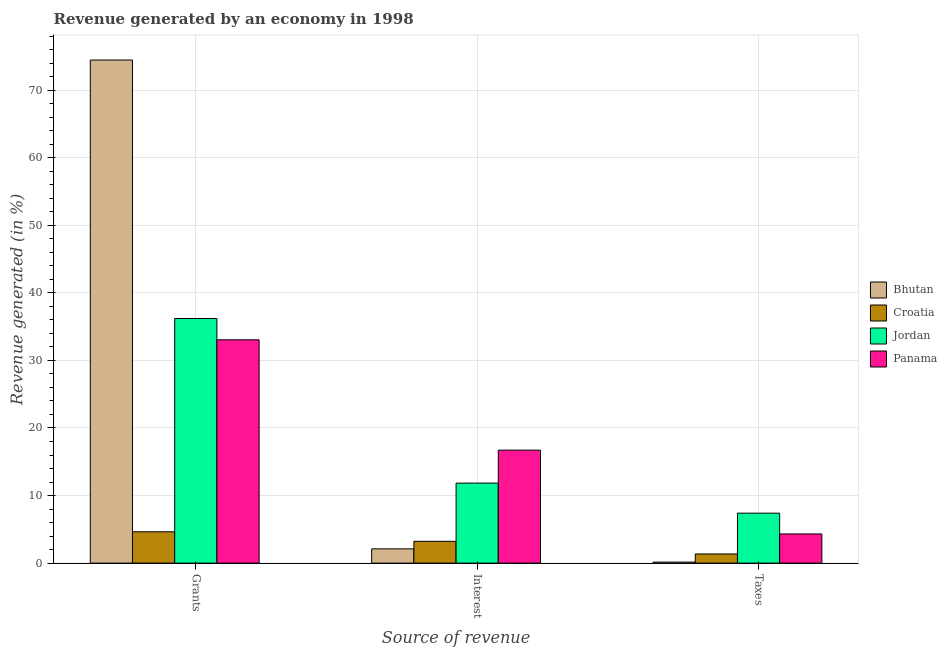Are the number of bars per tick equal to the number of legend labels?
Give a very brief answer. Yes. How many bars are there on the 3rd tick from the right?
Provide a succinct answer. 4. What is the label of the 3rd group of bars from the left?
Your response must be concise. Taxes. What is the percentage of revenue generated by taxes in Bhutan?
Offer a very short reply. 0.16. Across all countries, what is the maximum percentage of revenue generated by interest?
Your answer should be very brief. 16.72. Across all countries, what is the minimum percentage of revenue generated by interest?
Your answer should be very brief. 2.11. In which country was the percentage of revenue generated by taxes maximum?
Your response must be concise. Jordan. In which country was the percentage of revenue generated by taxes minimum?
Your answer should be compact. Bhutan. What is the total percentage of revenue generated by taxes in the graph?
Make the answer very short. 13.22. What is the difference between the percentage of revenue generated by grants in Bhutan and that in Jordan?
Provide a succinct answer. 38.25. What is the difference between the percentage of revenue generated by interest in Panama and the percentage of revenue generated by taxes in Bhutan?
Give a very brief answer. 16.56. What is the average percentage of revenue generated by grants per country?
Provide a short and direct response. 37.09. What is the difference between the percentage of revenue generated by taxes and percentage of revenue generated by interest in Croatia?
Keep it short and to the point. -1.87. In how many countries, is the percentage of revenue generated by taxes greater than 70 %?
Your answer should be compact. 0. What is the ratio of the percentage of revenue generated by grants in Bhutan to that in Croatia?
Your response must be concise. 16.06. What is the difference between the highest and the second highest percentage of revenue generated by interest?
Provide a short and direct response. 4.88. What is the difference between the highest and the lowest percentage of revenue generated by interest?
Provide a short and direct response. 14.61. In how many countries, is the percentage of revenue generated by taxes greater than the average percentage of revenue generated by taxes taken over all countries?
Provide a succinct answer. 2. Is the sum of the percentage of revenue generated by grants in Croatia and Bhutan greater than the maximum percentage of revenue generated by taxes across all countries?
Provide a succinct answer. Yes. What does the 3rd bar from the left in Grants represents?
Offer a very short reply. Jordan. What does the 3rd bar from the right in Grants represents?
Offer a terse response. Croatia. Is it the case that in every country, the sum of the percentage of revenue generated by grants and percentage of revenue generated by interest is greater than the percentage of revenue generated by taxes?
Provide a succinct answer. Yes. Are all the bars in the graph horizontal?
Your answer should be very brief. No. What is the difference between two consecutive major ticks on the Y-axis?
Offer a very short reply. 10. Are the values on the major ticks of Y-axis written in scientific E-notation?
Your answer should be very brief. No. Does the graph contain any zero values?
Keep it short and to the point. No. What is the title of the graph?
Provide a succinct answer. Revenue generated by an economy in 1998. Does "Brazil" appear as one of the legend labels in the graph?
Keep it short and to the point. No. What is the label or title of the X-axis?
Your answer should be compact. Source of revenue. What is the label or title of the Y-axis?
Provide a succinct answer. Revenue generated (in %). What is the Revenue generated (in %) in Bhutan in Grants?
Make the answer very short. 74.46. What is the Revenue generated (in %) of Croatia in Grants?
Your response must be concise. 4.64. What is the Revenue generated (in %) of Jordan in Grants?
Provide a short and direct response. 36.21. What is the Revenue generated (in %) of Panama in Grants?
Provide a succinct answer. 33.05. What is the Revenue generated (in %) in Bhutan in Interest?
Ensure brevity in your answer.  2.11. What is the Revenue generated (in %) of Croatia in Interest?
Give a very brief answer. 3.23. What is the Revenue generated (in %) in Jordan in Interest?
Provide a succinct answer. 11.84. What is the Revenue generated (in %) in Panama in Interest?
Give a very brief answer. 16.72. What is the Revenue generated (in %) in Bhutan in Taxes?
Keep it short and to the point. 0.16. What is the Revenue generated (in %) in Croatia in Taxes?
Ensure brevity in your answer.  1.36. What is the Revenue generated (in %) in Jordan in Taxes?
Give a very brief answer. 7.39. What is the Revenue generated (in %) of Panama in Taxes?
Your response must be concise. 4.32. Across all Source of revenue, what is the maximum Revenue generated (in %) in Bhutan?
Your answer should be very brief. 74.46. Across all Source of revenue, what is the maximum Revenue generated (in %) in Croatia?
Make the answer very short. 4.64. Across all Source of revenue, what is the maximum Revenue generated (in %) of Jordan?
Ensure brevity in your answer.  36.21. Across all Source of revenue, what is the maximum Revenue generated (in %) of Panama?
Provide a short and direct response. 33.05. Across all Source of revenue, what is the minimum Revenue generated (in %) in Bhutan?
Make the answer very short. 0.16. Across all Source of revenue, what is the minimum Revenue generated (in %) in Croatia?
Your response must be concise. 1.36. Across all Source of revenue, what is the minimum Revenue generated (in %) of Jordan?
Your answer should be compact. 7.39. Across all Source of revenue, what is the minimum Revenue generated (in %) of Panama?
Your response must be concise. 4.32. What is the total Revenue generated (in %) of Bhutan in the graph?
Keep it short and to the point. 76.73. What is the total Revenue generated (in %) in Croatia in the graph?
Your answer should be compact. 9.22. What is the total Revenue generated (in %) in Jordan in the graph?
Provide a succinct answer. 55.44. What is the total Revenue generated (in %) of Panama in the graph?
Make the answer very short. 54.09. What is the difference between the Revenue generated (in %) in Bhutan in Grants and that in Interest?
Offer a very short reply. 72.35. What is the difference between the Revenue generated (in %) in Croatia in Grants and that in Interest?
Keep it short and to the point. 1.41. What is the difference between the Revenue generated (in %) in Jordan in Grants and that in Interest?
Your response must be concise. 24.37. What is the difference between the Revenue generated (in %) in Panama in Grants and that in Interest?
Offer a very short reply. 16.33. What is the difference between the Revenue generated (in %) in Bhutan in Grants and that in Taxes?
Provide a short and direct response. 74.3. What is the difference between the Revenue generated (in %) in Croatia in Grants and that in Taxes?
Keep it short and to the point. 3.28. What is the difference between the Revenue generated (in %) of Jordan in Grants and that in Taxes?
Give a very brief answer. 28.82. What is the difference between the Revenue generated (in %) in Panama in Grants and that in Taxes?
Give a very brief answer. 28.73. What is the difference between the Revenue generated (in %) of Bhutan in Interest and that in Taxes?
Make the answer very short. 1.96. What is the difference between the Revenue generated (in %) in Croatia in Interest and that in Taxes?
Provide a succinct answer. 1.87. What is the difference between the Revenue generated (in %) in Jordan in Interest and that in Taxes?
Provide a short and direct response. 4.45. What is the difference between the Revenue generated (in %) in Panama in Interest and that in Taxes?
Offer a very short reply. 12.4. What is the difference between the Revenue generated (in %) of Bhutan in Grants and the Revenue generated (in %) of Croatia in Interest?
Offer a very short reply. 71.23. What is the difference between the Revenue generated (in %) in Bhutan in Grants and the Revenue generated (in %) in Jordan in Interest?
Make the answer very short. 62.62. What is the difference between the Revenue generated (in %) in Bhutan in Grants and the Revenue generated (in %) in Panama in Interest?
Make the answer very short. 57.74. What is the difference between the Revenue generated (in %) of Croatia in Grants and the Revenue generated (in %) of Jordan in Interest?
Keep it short and to the point. -7.2. What is the difference between the Revenue generated (in %) of Croatia in Grants and the Revenue generated (in %) of Panama in Interest?
Provide a succinct answer. -12.08. What is the difference between the Revenue generated (in %) of Jordan in Grants and the Revenue generated (in %) of Panama in Interest?
Your answer should be very brief. 19.49. What is the difference between the Revenue generated (in %) in Bhutan in Grants and the Revenue generated (in %) in Croatia in Taxes?
Your answer should be compact. 73.1. What is the difference between the Revenue generated (in %) in Bhutan in Grants and the Revenue generated (in %) in Jordan in Taxes?
Offer a very short reply. 67.07. What is the difference between the Revenue generated (in %) in Bhutan in Grants and the Revenue generated (in %) in Panama in Taxes?
Make the answer very short. 70.14. What is the difference between the Revenue generated (in %) of Croatia in Grants and the Revenue generated (in %) of Jordan in Taxes?
Provide a short and direct response. -2.76. What is the difference between the Revenue generated (in %) in Croatia in Grants and the Revenue generated (in %) in Panama in Taxes?
Your response must be concise. 0.32. What is the difference between the Revenue generated (in %) of Jordan in Grants and the Revenue generated (in %) of Panama in Taxes?
Give a very brief answer. 31.89. What is the difference between the Revenue generated (in %) of Bhutan in Interest and the Revenue generated (in %) of Croatia in Taxes?
Provide a short and direct response. 0.75. What is the difference between the Revenue generated (in %) in Bhutan in Interest and the Revenue generated (in %) in Jordan in Taxes?
Your answer should be very brief. -5.28. What is the difference between the Revenue generated (in %) of Bhutan in Interest and the Revenue generated (in %) of Panama in Taxes?
Your answer should be very brief. -2.21. What is the difference between the Revenue generated (in %) in Croatia in Interest and the Revenue generated (in %) in Jordan in Taxes?
Keep it short and to the point. -4.17. What is the difference between the Revenue generated (in %) of Croatia in Interest and the Revenue generated (in %) of Panama in Taxes?
Provide a succinct answer. -1.09. What is the difference between the Revenue generated (in %) in Jordan in Interest and the Revenue generated (in %) in Panama in Taxes?
Ensure brevity in your answer.  7.52. What is the average Revenue generated (in %) of Bhutan per Source of revenue?
Ensure brevity in your answer.  25.58. What is the average Revenue generated (in %) of Croatia per Source of revenue?
Keep it short and to the point. 3.07. What is the average Revenue generated (in %) of Jordan per Source of revenue?
Give a very brief answer. 18.48. What is the average Revenue generated (in %) of Panama per Source of revenue?
Offer a terse response. 18.03. What is the difference between the Revenue generated (in %) in Bhutan and Revenue generated (in %) in Croatia in Grants?
Keep it short and to the point. 69.82. What is the difference between the Revenue generated (in %) of Bhutan and Revenue generated (in %) of Jordan in Grants?
Make the answer very short. 38.25. What is the difference between the Revenue generated (in %) in Bhutan and Revenue generated (in %) in Panama in Grants?
Your answer should be very brief. 41.41. What is the difference between the Revenue generated (in %) in Croatia and Revenue generated (in %) in Jordan in Grants?
Provide a succinct answer. -31.57. What is the difference between the Revenue generated (in %) of Croatia and Revenue generated (in %) of Panama in Grants?
Your answer should be very brief. -28.41. What is the difference between the Revenue generated (in %) of Jordan and Revenue generated (in %) of Panama in Grants?
Provide a succinct answer. 3.16. What is the difference between the Revenue generated (in %) of Bhutan and Revenue generated (in %) of Croatia in Interest?
Provide a succinct answer. -1.11. What is the difference between the Revenue generated (in %) of Bhutan and Revenue generated (in %) of Jordan in Interest?
Give a very brief answer. -9.73. What is the difference between the Revenue generated (in %) in Bhutan and Revenue generated (in %) in Panama in Interest?
Your response must be concise. -14.61. What is the difference between the Revenue generated (in %) in Croatia and Revenue generated (in %) in Jordan in Interest?
Make the answer very short. -8.61. What is the difference between the Revenue generated (in %) of Croatia and Revenue generated (in %) of Panama in Interest?
Give a very brief answer. -13.49. What is the difference between the Revenue generated (in %) in Jordan and Revenue generated (in %) in Panama in Interest?
Your answer should be very brief. -4.88. What is the difference between the Revenue generated (in %) in Bhutan and Revenue generated (in %) in Croatia in Taxes?
Offer a very short reply. -1.2. What is the difference between the Revenue generated (in %) of Bhutan and Revenue generated (in %) of Jordan in Taxes?
Offer a terse response. -7.24. What is the difference between the Revenue generated (in %) of Bhutan and Revenue generated (in %) of Panama in Taxes?
Your answer should be compact. -4.16. What is the difference between the Revenue generated (in %) of Croatia and Revenue generated (in %) of Jordan in Taxes?
Your answer should be very brief. -6.04. What is the difference between the Revenue generated (in %) in Croatia and Revenue generated (in %) in Panama in Taxes?
Offer a terse response. -2.96. What is the difference between the Revenue generated (in %) in Jordan and Revenue generated (in %) in Panama in Taxes?
Offer a terse response. 3.08. What is the ratio of the Revenue generated (in %) in Bhutan in Grants to that in Interest?
Give a very brief answer. 35.28. What is the ratio of the Revenue generated (in %) in Croatia in Grants to that in Interest?
Give a very brief answer. 1.44. What is the ratio of the Revenue generated (in %) in Jordan in Grants to that in Interest?
Keep it short and to the point. 3.06. What is the ratio of the Revenue generated (in %) in Panama in Grants to that in Interest?
Keep it short and to the point. 1.98. What is the ratio of the Revenue generated (in %) of Bhutan in Grants to that in Taxes?
Your answer should be compact. 478.62. What is the ratio of the Revenue generated (in %) in Croatia in Grants to that in Taxes?
Keep it short and to the point. 3.42. What is the ratio of the Revenue generated (in %) in Jordan in Grants to that in Taxes?
Your response must be concise. 4.9. What is the ratio of the Revenue generated (in %) of Panama in Grants to that in Taxes?
Keep it short and to the point. 7.66. What is the ratio of the Revenue generated (in %) in Bhutan in Interest to that in Taxes?
Give a very brief answer. 13.57. What is the ratio of the Revenue generated (in %) of Croatia in Interest to that in Taxes?
Your answer should be compact. 2.38. What is the ratio of the Revenue generated (in %) of Jordan in Interest to that in Taxes?
Your response must be concise. 1.6. What is the ratio of the Revenue generated (in %) in Panama in Interest to that in Taxes?
Offer a very short reply. 3.87. What is the difference between the highest and the second highest Revenue generated (in %) in Bhutan?
Your answer should be compact. 72.35. What is the difference between the highest and the second highest Revenue generated (in %) of Croatia?
Give a very brief answer. 1.41. What is the difference between the highest and the second highest Revenue generated (in %) of Jordan?
Keep it short and to the point. 24.37. What is the difference between the highest and the second highest Revenue generated (in %) in Panama?
Keep it short and to the point. 16.33. What is the difference between the highest and the lowest Revenue generated (in %) of Bhutan?
Keep it short and to the point. 74.3. What is the difference between the highest and the lowest Revenue generated (in %) of Croatia?
Offer a terse response. 3.28. What is the difference between the highest and the lowest Revenue generated (in %) in Jordan?
Provide a succinct answer. 28.82. What is the difference between the highest and the lowest Revenue generated (in %) of Panama?
Offer a very short reply. 28.73. 